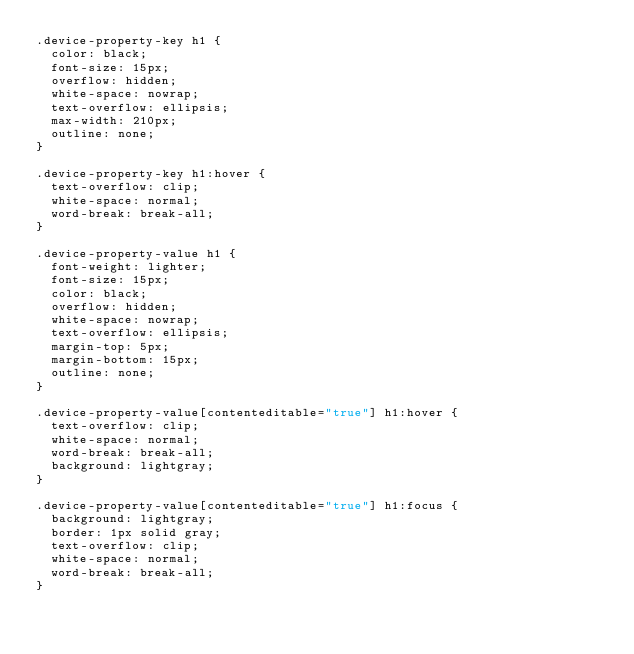Convert code to text. <code><loc_0><loc_0><loc_500><loc_500><_CSS_>.device-property-key h1 {
  color: black;
  font-size: 15px;
  overflow: hidden;
  white-space: nowrap;
  text-overflow: ellipsis;
  max-width: 210px;
  outline: none;
}

.device-property-key h1:hover {
  text-overflow: clip;
  white-space: normal;
  word-break: break-all;
}

.device-property-value h1 {
  font-weight: lighter;
  font-size: 15px;
  color: black;
  overflow: hidden;
  white-space: nowrap;
  text-overflow: ellipsis;
  margin-top: 5px;
  margin-bottom: 15px;
  outline: none;
}

.device-property-value[contenteditable="true"] h1:hover {
  text-overflow: clip;
  white-space: normal;
  word-break: break-all;
  background: lightgray;
}

.device-property-value[contenteditable="true"] h1:focus {
  background: lightgray;
  border: 1px solid gray;
  text-overflow: clip;
  white-space: normal;
  word-break: break-all;
}
</code> 